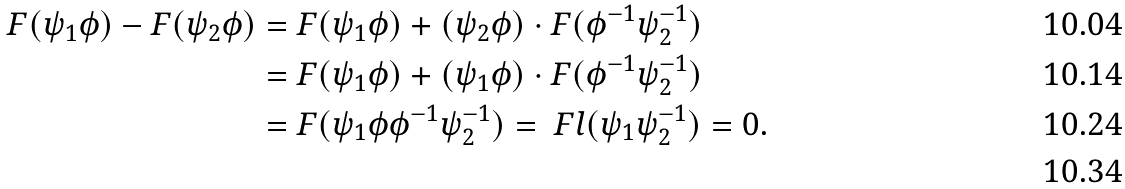Convert formula to latex. <formula><loc_0><loc_0><loc_500><loc_500>F ( \psi _ { 1 } \phi ) - F ( \psi _ { 2 } \phi ) & = F ( \psi _ { 1 } \phi ) + ( \psi _ { 2 } \phi ) \cdot F ( \phi ^ { - 1 } \psi _ { 2 } ^ { - 1 } ) \\ & = F ( \psi _ { 1 } \phi ) + ( \psi _ { 1 } \phi ) \cdot F ( \phi ^ { - 1 } \psi _ { 2 } ^ { - 1 } ) \\ & = F ( \psi _ { 1 } \phi \phi ^ { - 1 } \psi _ { 2 } ^ { - 1 } ) = \ F l ( \psi _ { 1 } \psi _ { 2 } ^ { - 1 } ) = 0 . \\</formula> 